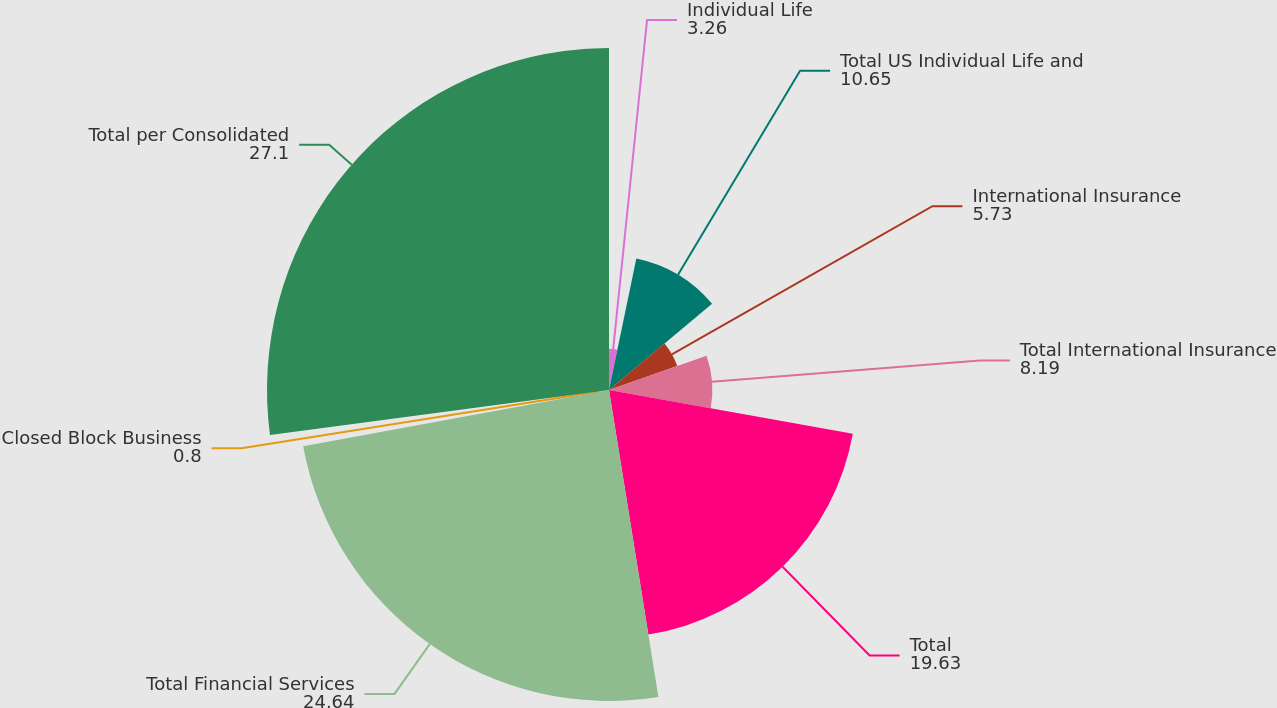Convert chart to OTSL. <chart><loc_0><loc_0><loc_500><loc_500><pie_chart><fcel>Individual Life<fcel>Total US Individual Life and<fcel>International Insurance<fcel>Total International Insurance<fcel>Total<fcel>Total Financial Services<fcel>Closed Block Business<fcel>Total per Consolidated<nl><fcel>3.26%<fcel>10.65%<fcel>5.73%<fcel>8.19%<fcel>19.63%<fcel>24.64%<fcel>0.8%<fcel>27.1%<nl></chart> 